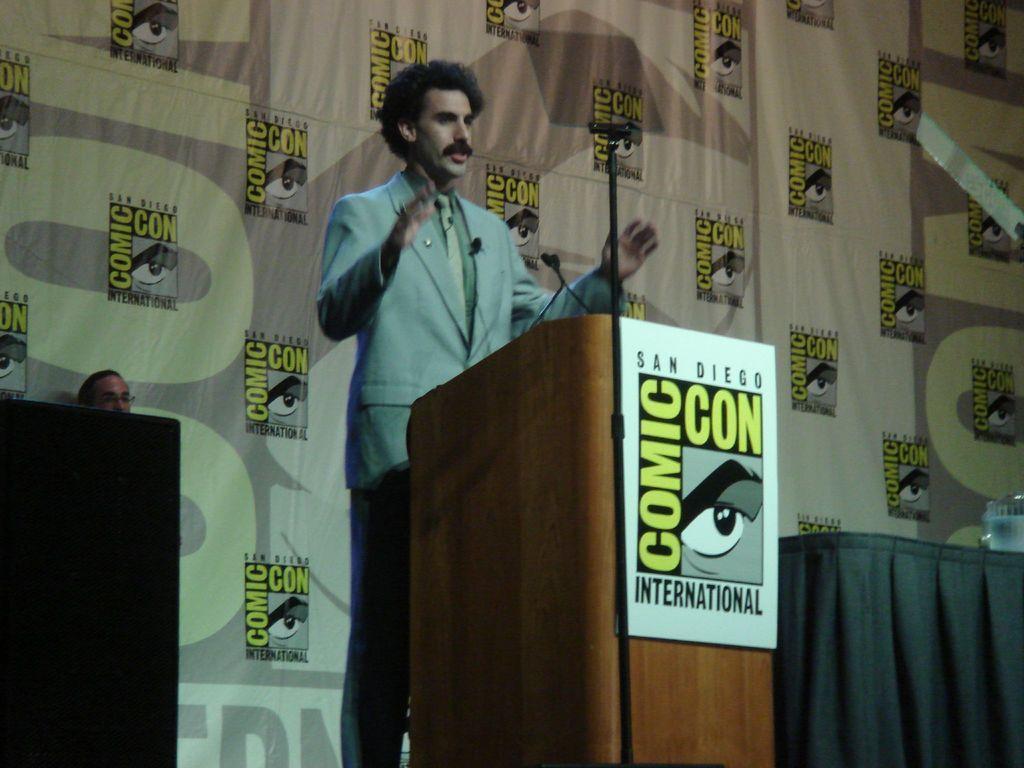In one or two sentences, can you explain what this image depicts? In the image there is a podium with poster. On the podium there are mics. Behind the podium there is a man standing. On the left side of the image there is a speaker. And on the right side of the image there is a table with an object. Behind him there is a banner with images. And also there is a man. 